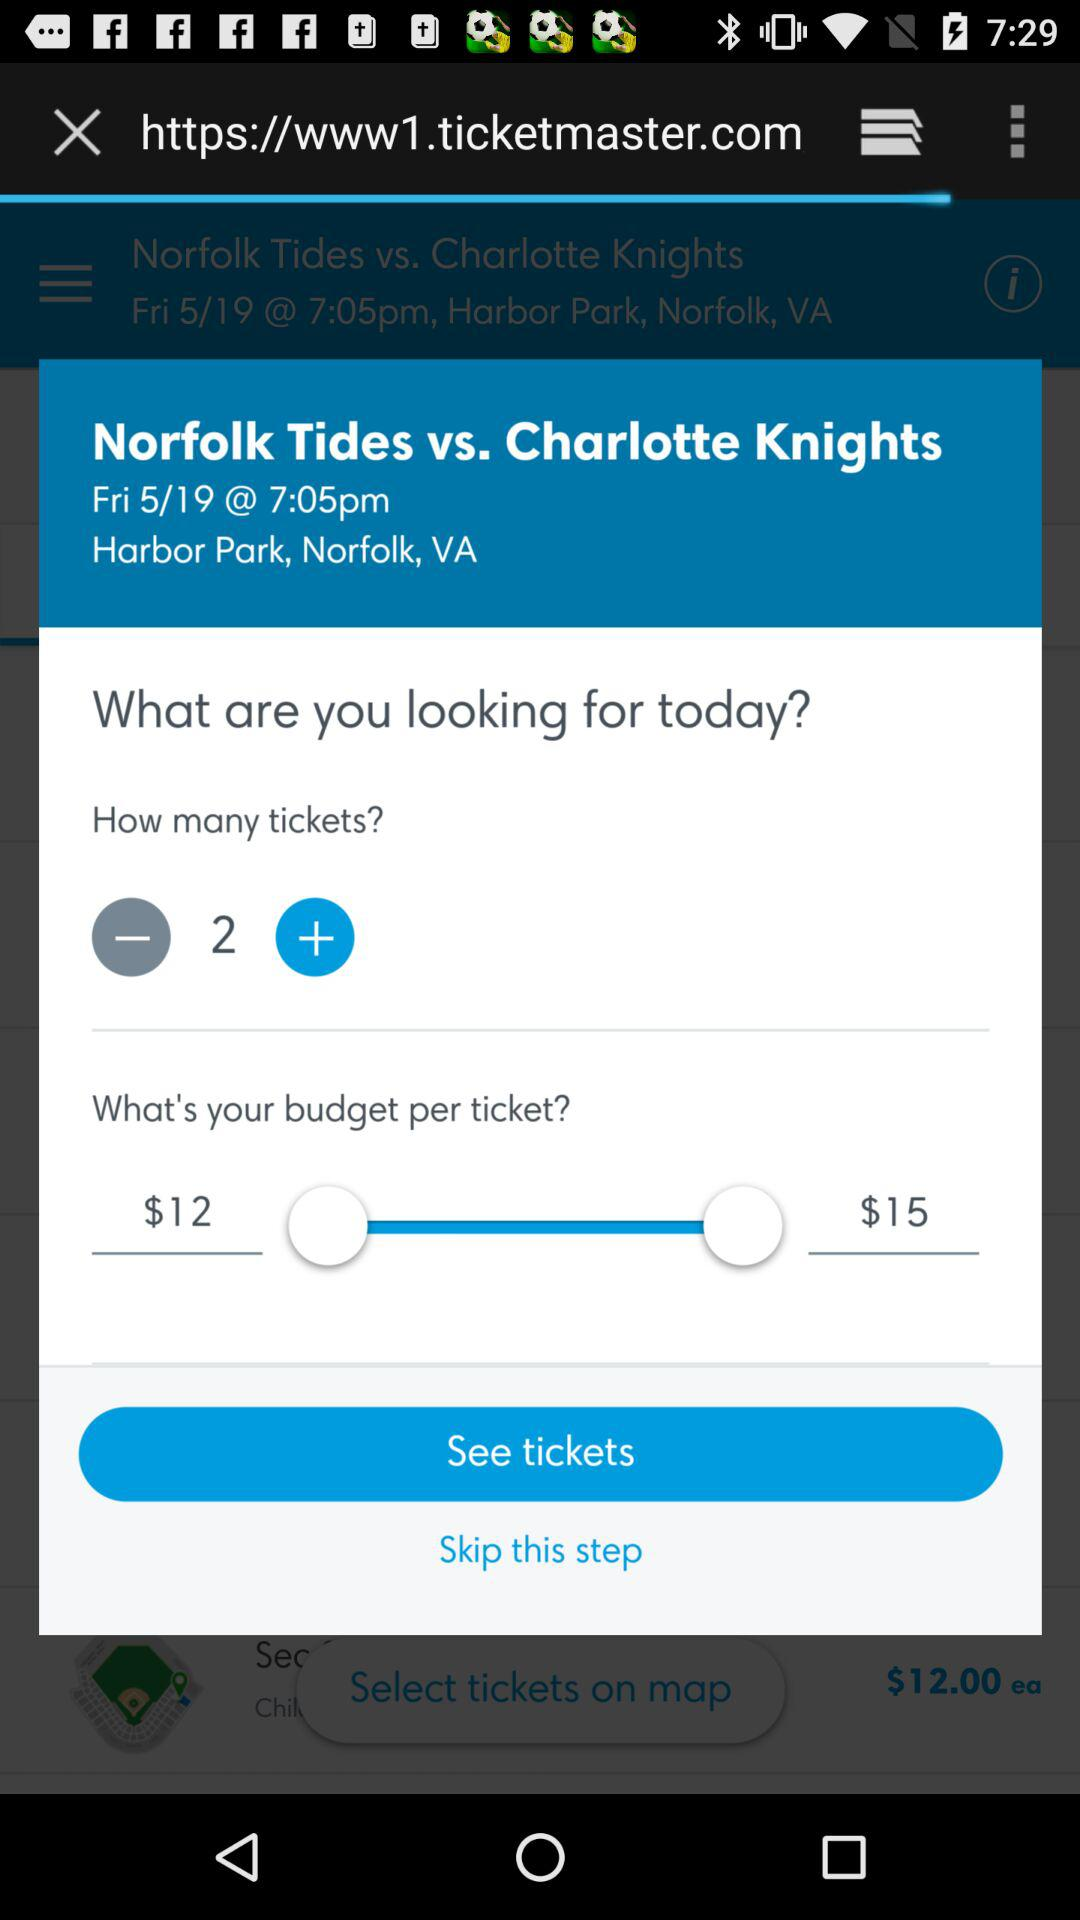What is the location? The location is Harbor Park, Norfolk, VA. 